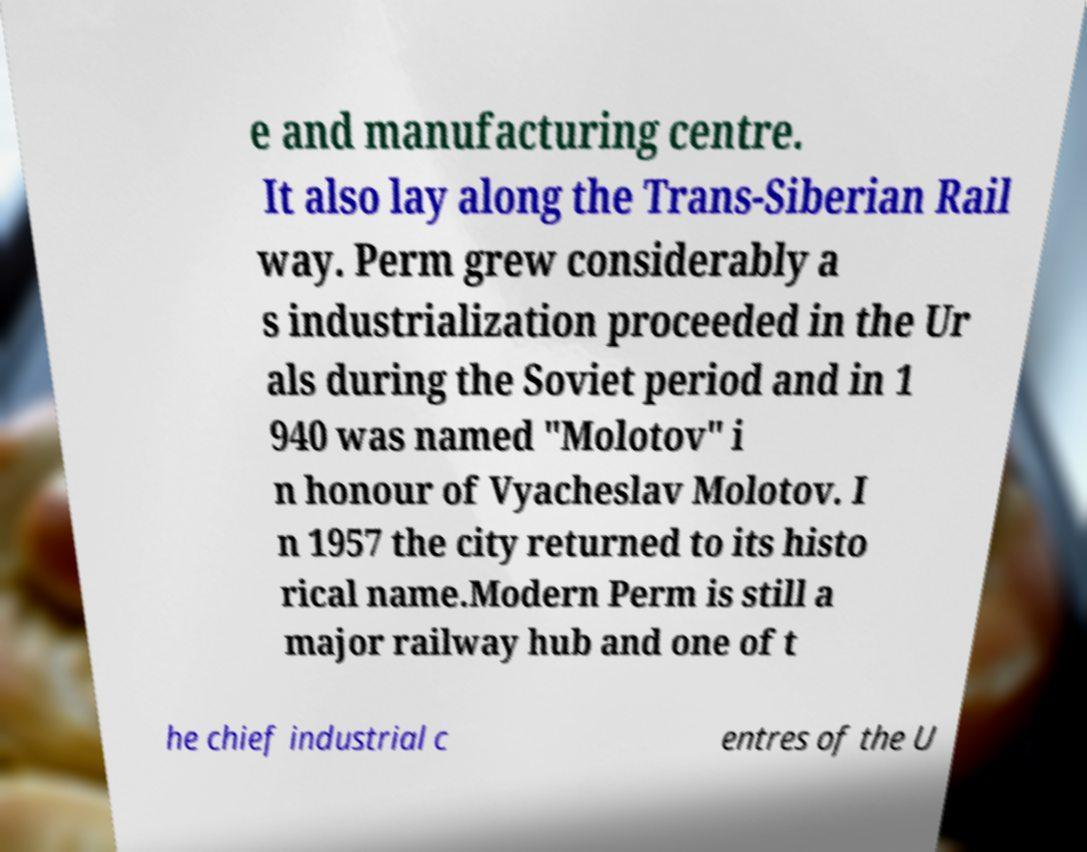Could you assist in decoding the text presented in this image and type it out clearly? e and manufacturing centre. It also lay along the Trans-Siberian Rail way. Perm grew considerably a s industrialization proceeded in the Ur als during the Soviet period and in 1 940 was named "Molotov" i n honour of Vyacheslav Molotov. I n 1957 the city returned to its histo rical name.Modern Perm is still a major railway hub and one of t he chief industrial c entres of the U 